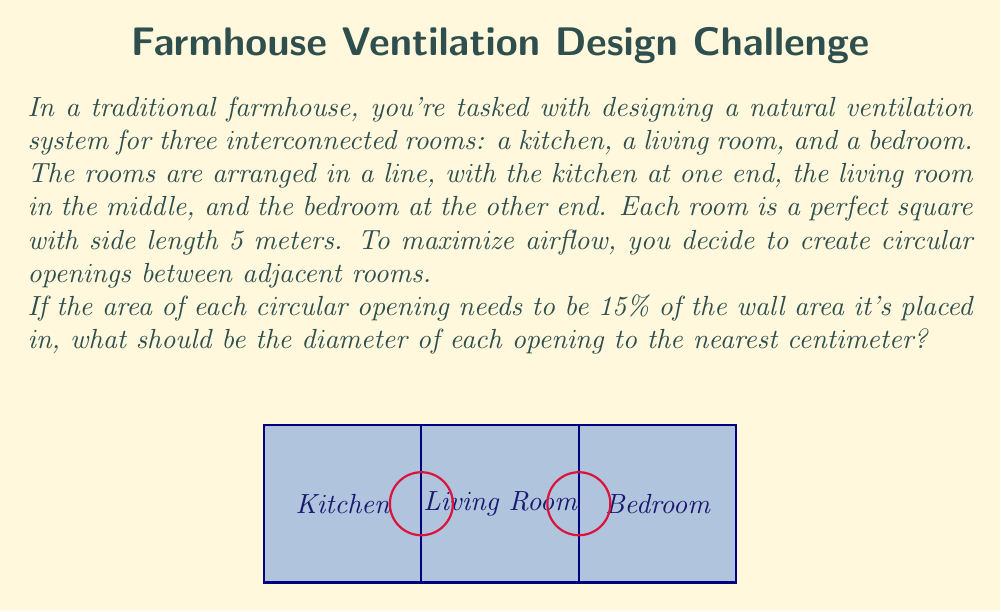Can you answer this question? Let's approach this step-by-step:

1) First, we need to calculate the area of the wall between two rooms:
   Wall area = $5 \text{ m} \times 5 \text{ m} = 25 \text{ m}^2$

2) The circular opening should be 15% of this area:
   Opening area = $15\% \text{ of } 25 \text{ m}^2 = 0.15 \times 25 \text{ m}^2 = 3.75 \text{ m}^2$

3) Now, we need to find the diameter of a circle with this area. Let's recall the formula for the area of a circle:
   $A = \pi r^2$, where $A$ is the area and $r$ is the radius

4) We can rearrange this to solve for $r$:
   $r = \sqrt{\frac{A}{\pi}}$

5) Substituting our values:
   $r = \sqrt{\frac{3.75 \text{ m}^2}{\pi}} \approx 1.093 \text{ m}$

6) The diameter is twice the radius:
   $d = 2r \approx 2.186 \text{ m}$

7) Converting to centimeters and rounding to the nearest centimeter:
   $d \approx 219 \text{ cm}$
Answer: 219 cm 